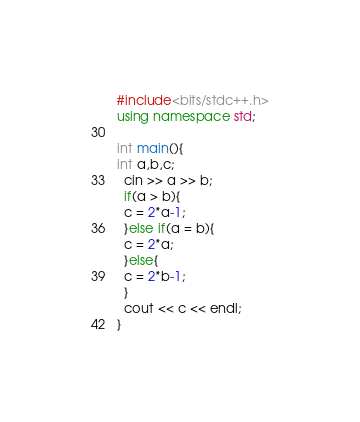Convert code to text. <code><loc_0><loc_0><loc_500><loc_500><_C++_>#include<bits/stdc++.h>
using namespace std;

int main(){
int a,b,c;
  cin >> a >> b;
  if(a > b){
  c = 2*a-1;
  }else if(a = b){
  c = 2*a;
  }else{
  c = 2*b-1;
  }
  cout << c << endl;
}</code> 